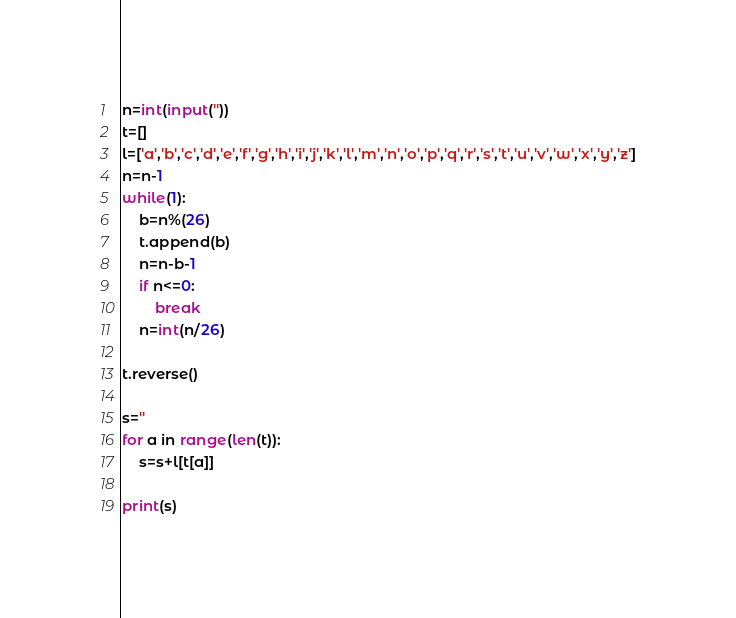Convert code to text. <code><loc_0><loc_0><loc_500><loc_500><_Python_>n=int(input(''))
t=[]
l=['a','b','c','d','e','f','g','h','i','j','k','l','m','n','o','p','q','r','s','t','u','v','w','x','y','z']
n=n-1
while(1):
    b=n%(26)
    t.append(b)
    n=n-b-1
    if n<=0:
        break
    n=int(n/26)
    
t.reverse()
 
s=''
for a in range(len(t)):
    s=s+l[t[a]]
 
print(s)</code> 